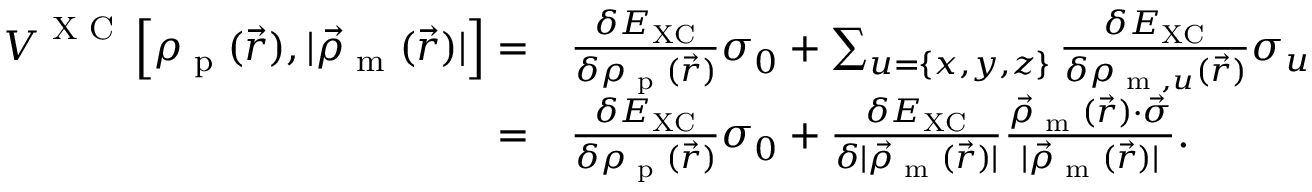Convert formula to latex. <formula><loc_0><loc_0><loc_500><loc_500>\begin{array} { r l } { V ^ { X C } \left [ \rho _ { p } ( \vec { r } ) , | \vec { \rho } _ { m } ( \vec { r } ) | \right ] = } & { \frac { \delta E _ { X C } } { \delta \rho _ { p } ( \vec { r } ) } \sigma _ { 0 } + \sum _ { u = \{ x , y , z \} } \frac { \delta E _ { X C } } { \delta \rho _ { m , u } ( \vec { r } ) } \sigma _ { u } } \\ { = } & { \frac { \delta E _ { X C } } { \delta \rho _ { p } ( \vec { r } ) } \sigma _ { 0 } + \frac { \delta E _ { X C } } { \delta | \vec { \rho } _ { m } ( \vec { r } ) | } \frac { \vec { \rho } _ { m } ( \vec { r } ) \cdot \vec { \sigma } } { | \vec { \rho } _ { m } ( \vec { r } ) | } . } \end{array}</formula> 